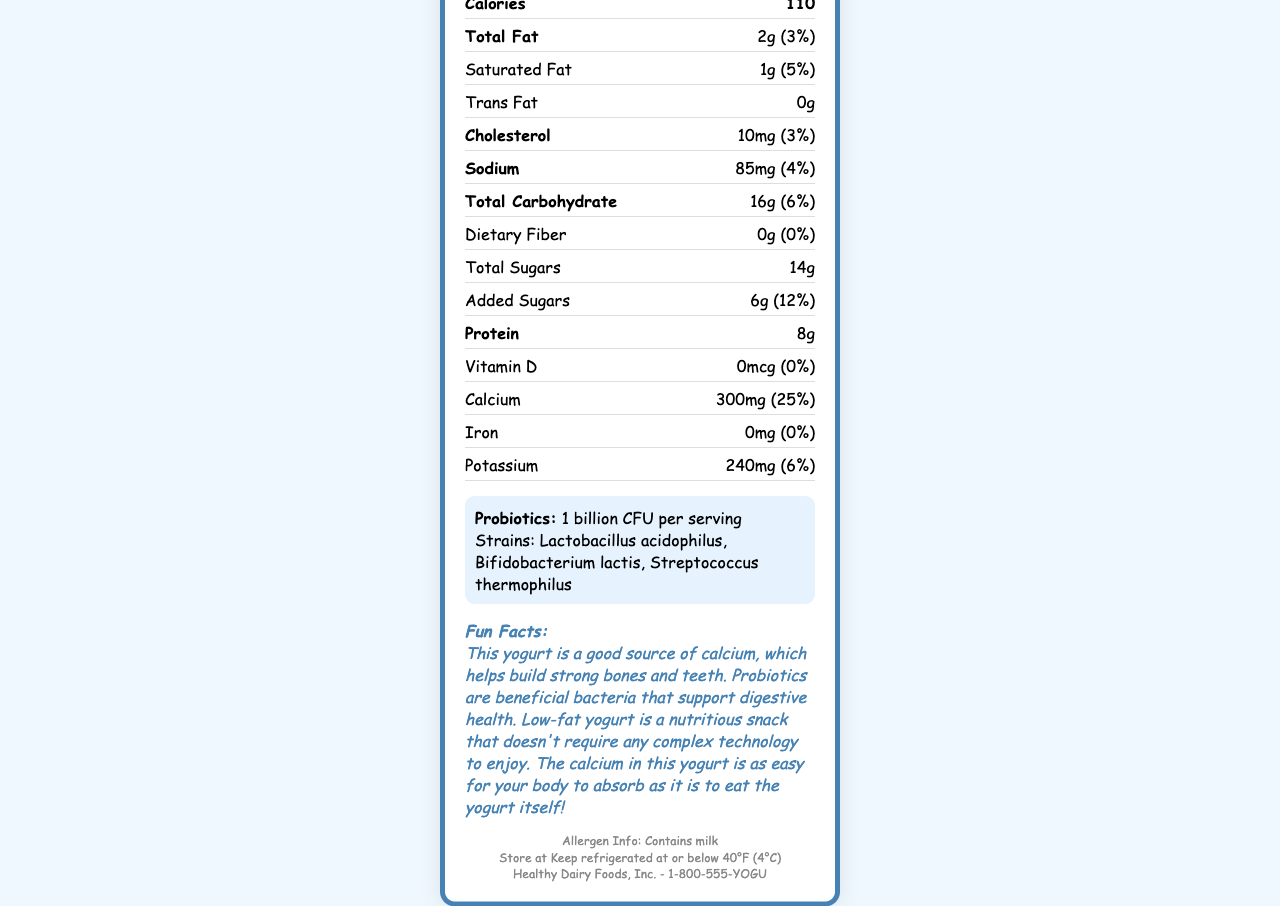what is the serving size? The serving size is indicated in the document's "Serving size" section as 150g (2/3 cup).
Answer: 150g (2/3 cup) how many calories are in one serving? The calorie count can be seen in the "Calories" row of the Nutrition Facts table.
Answer: 110 what percentage of the daily value of calcium does one serving provide? The daily value percentage for calcium is listed in the Nutrition Facts under "Calcium" as 25%.
Answer: 25% what are the probiotic strains included in the yogurt? The strains of probiotics are listed in the section dedicated to probiotics.
Answer: Lactobacillus acidophilus, Bifidobacterium lactis, Streptococcus thermophilus how much protein is in one serving? The amount of protein per serving is listed in the Nutrition Facts under "Protein" as 8g.
Answer: 8g how many grams of total sugars are in the yogurt? The total sugars in the yogurt are 14g as listed in the document.
Answer: 14g which ingredient is first on the list? A. Sugar B. Pectin C. Cultured low-fat milk D. Modified corn starch The first ingredient listed in the "Ingredients" section is "Cultured low-fat milk".
Answer: C. Cultured low-fat milk what is the daily value percentage of sodium? A. 3% B. 4% C. 6% D. 10% The daily value percentage of sodium is listed in the Nutrition Facts as 4%.
Answer: B. 4% does the yogurt contain any trans fat? The amount of trans fat is listed as 0g, indicating that the yogurt contains no trans fat.
Answer: No summarize the nutritional benefits and features of this yogurt. The summary is based on the nutritional details, probiotics information, and easy-to-understand facts provided in the document.
Answer: This yogurt provides a healthy, low-fat option with valuable nutrients like calcium and protein while incorporating beneficial probiotics for digestive health. It contains 110 calories per serving with low amounts of total fat (2g) and no trans fat. The yogurt offers 25% of the daily value of calcium and includes three strains of probiotics: Lactobacillus acidophilus, Bifidobacterium lactis, and Streptococcus thermophilus. is this yogurt a good source of Vitamin D? The Vitamin D content is 0mcg with 0% daily value, indicating that the yogurt is not a good source of Vitamin D.
Answer: No what is the expiration date of this yogurt? The document details the format for the expiration date but does not provide the specific expiration date for this yogurt container.
Answer: Not enough information 